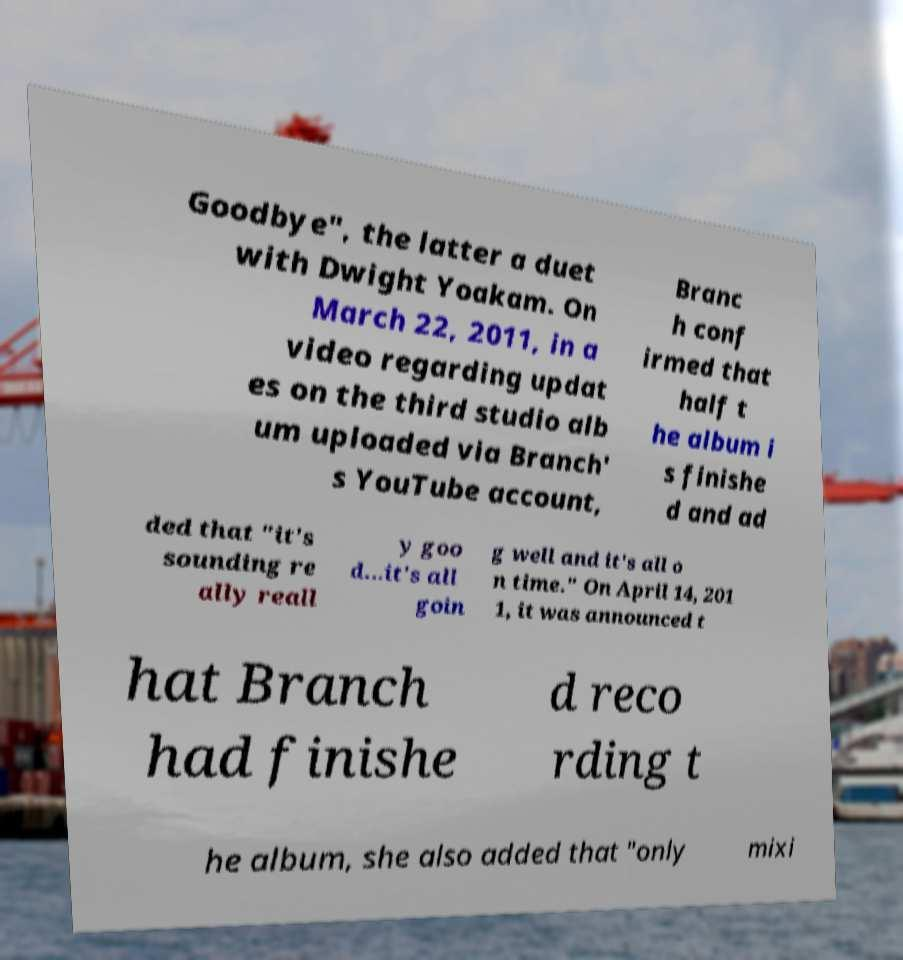Could you assist in decoding the text presented in this image and type it out clearly? Goodbye", the latter a duet with Dwight Yoakam. On March 22, 2011, in a video regarding updat es on the third studio alb um uploaded via Branch' s YouTube account, Branc h conf irmed that half t he album i s finishe d and ad ded that "it's sounding re ally reall y goo d...it's all goin g well and it's all o n time." On April 14, 201 1, it was announced t hat Branch had finishe d reco rding t he album, she also added that "only mixi 